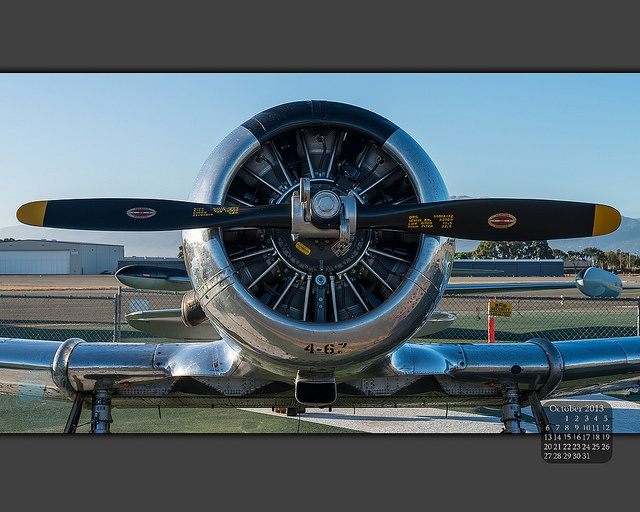Describe the objects in this image and their specific colors. I can see a airplane in black, gray, teal, and blue tones in this image. 